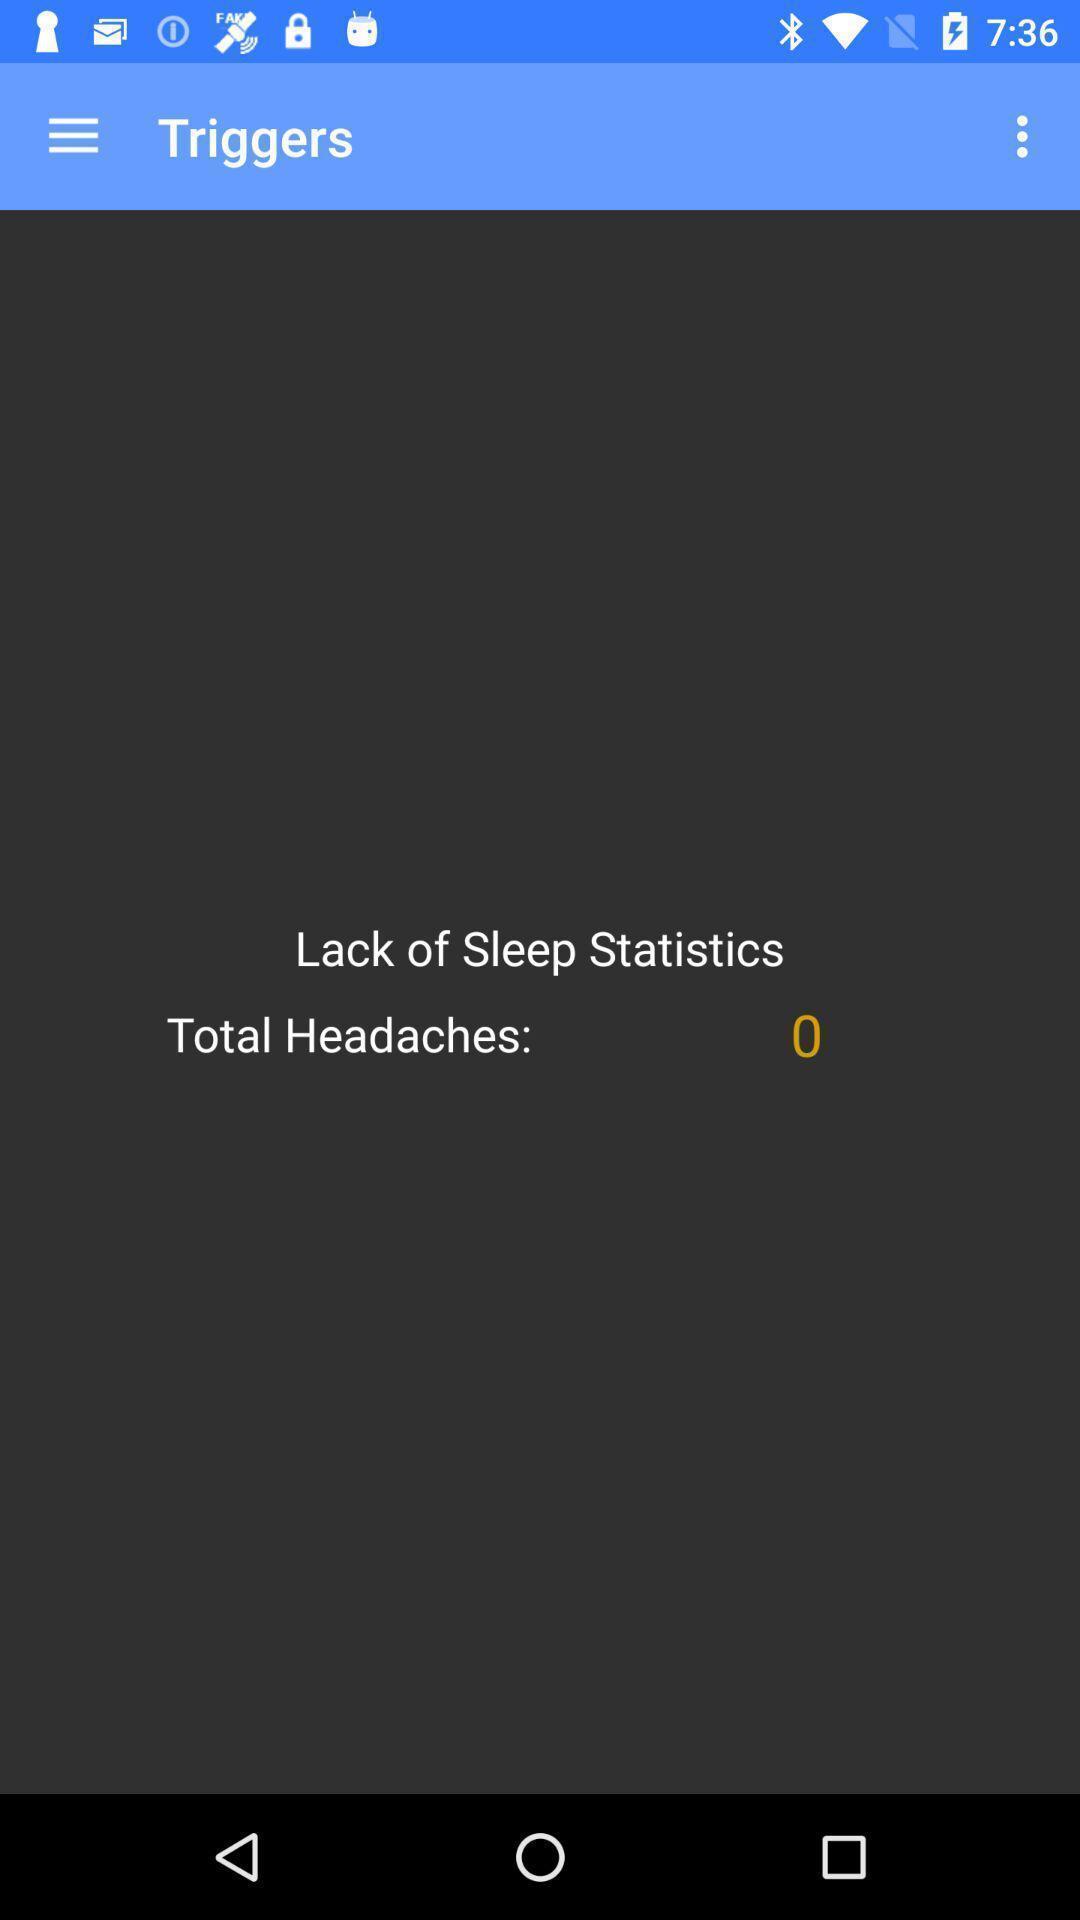Provide a description of this screenshot. Page showing to track your headaches and migraines. 